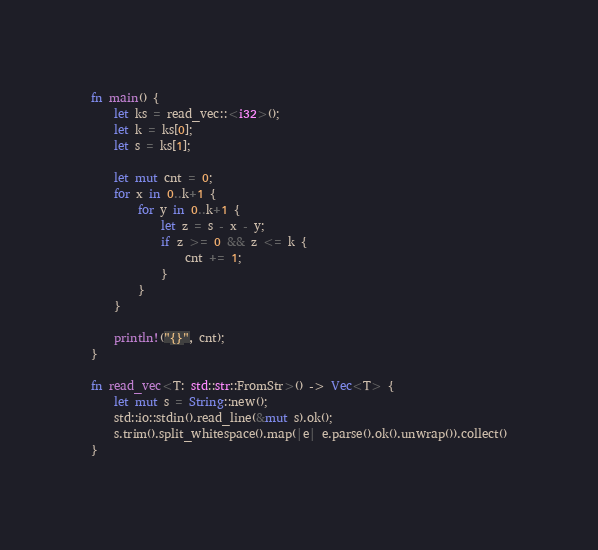Convert code to text. <code><loc_0><loc_0><loc_500><loc_500><_Rust_>fn main() {
    let ks = read_vec::<i32>();
    let k = ks[0];
    let s = ks[1];

    let mut cnt = 0;
    for x in 0..k+1 {
        for y in 0..k+1 {
            let z = s - x - y;
            if z >= 0 && z <= k {
                cnt += 1;
            }
        }
    }

    println!("{}", cnt);
}

fn read_vec<T: std::str::FromStr>() -> Vec<T> {
    let mut s = String::new();
    std::io::stdin().read_line(&mut s).ok();
    s.trim().split_whitespace().map(|e| e.parse().ok().unwrap()).collect()
}</code> 